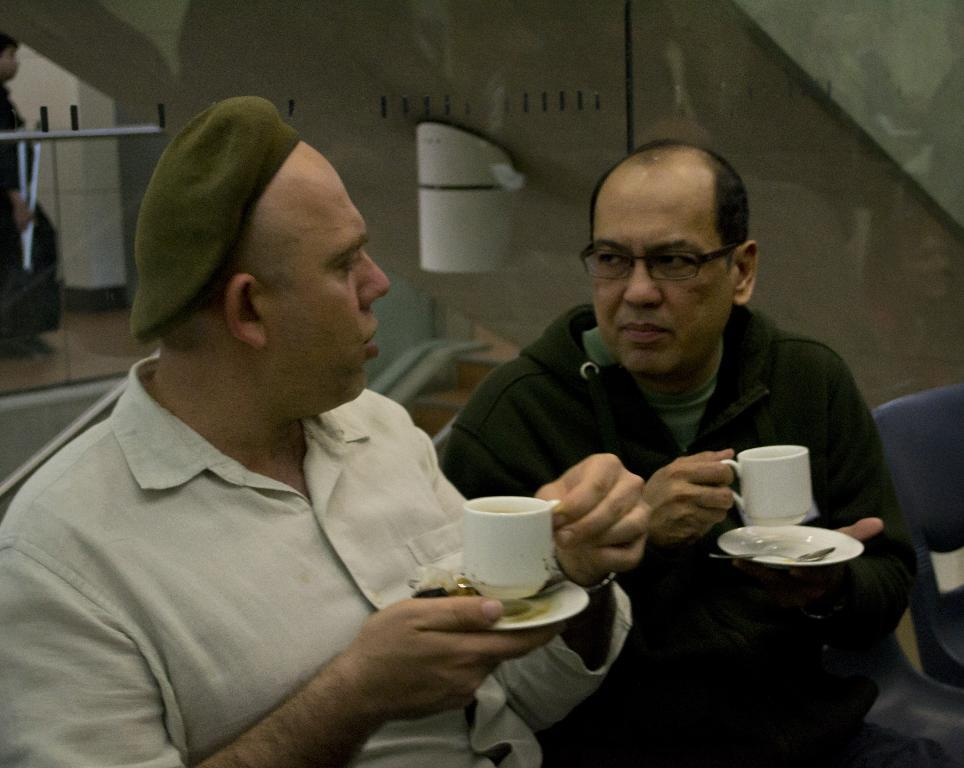How many people are in the image? There are two persons in the image. What are the persons doing in the image? The persons are sitting on chairs. What objects are the persons holding in the image? The persons are holding cups and saucers. What type of bread can be seen on the table in the image? There is no bread present in the image; the persons are holding cups and saucers. 